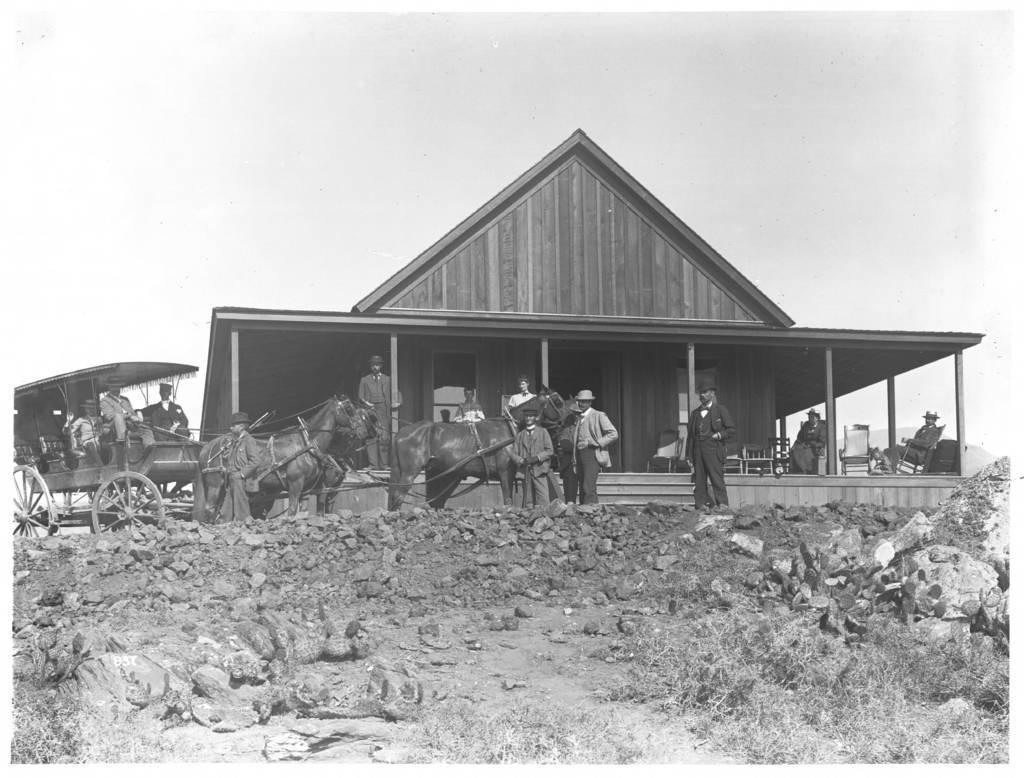Please provide a concise description of this image. This is a black and white image. At the bottom there are stones on the ground. In the middle of the image there is a house, cart and some people are standing. At the top of the image I can see the sky. 